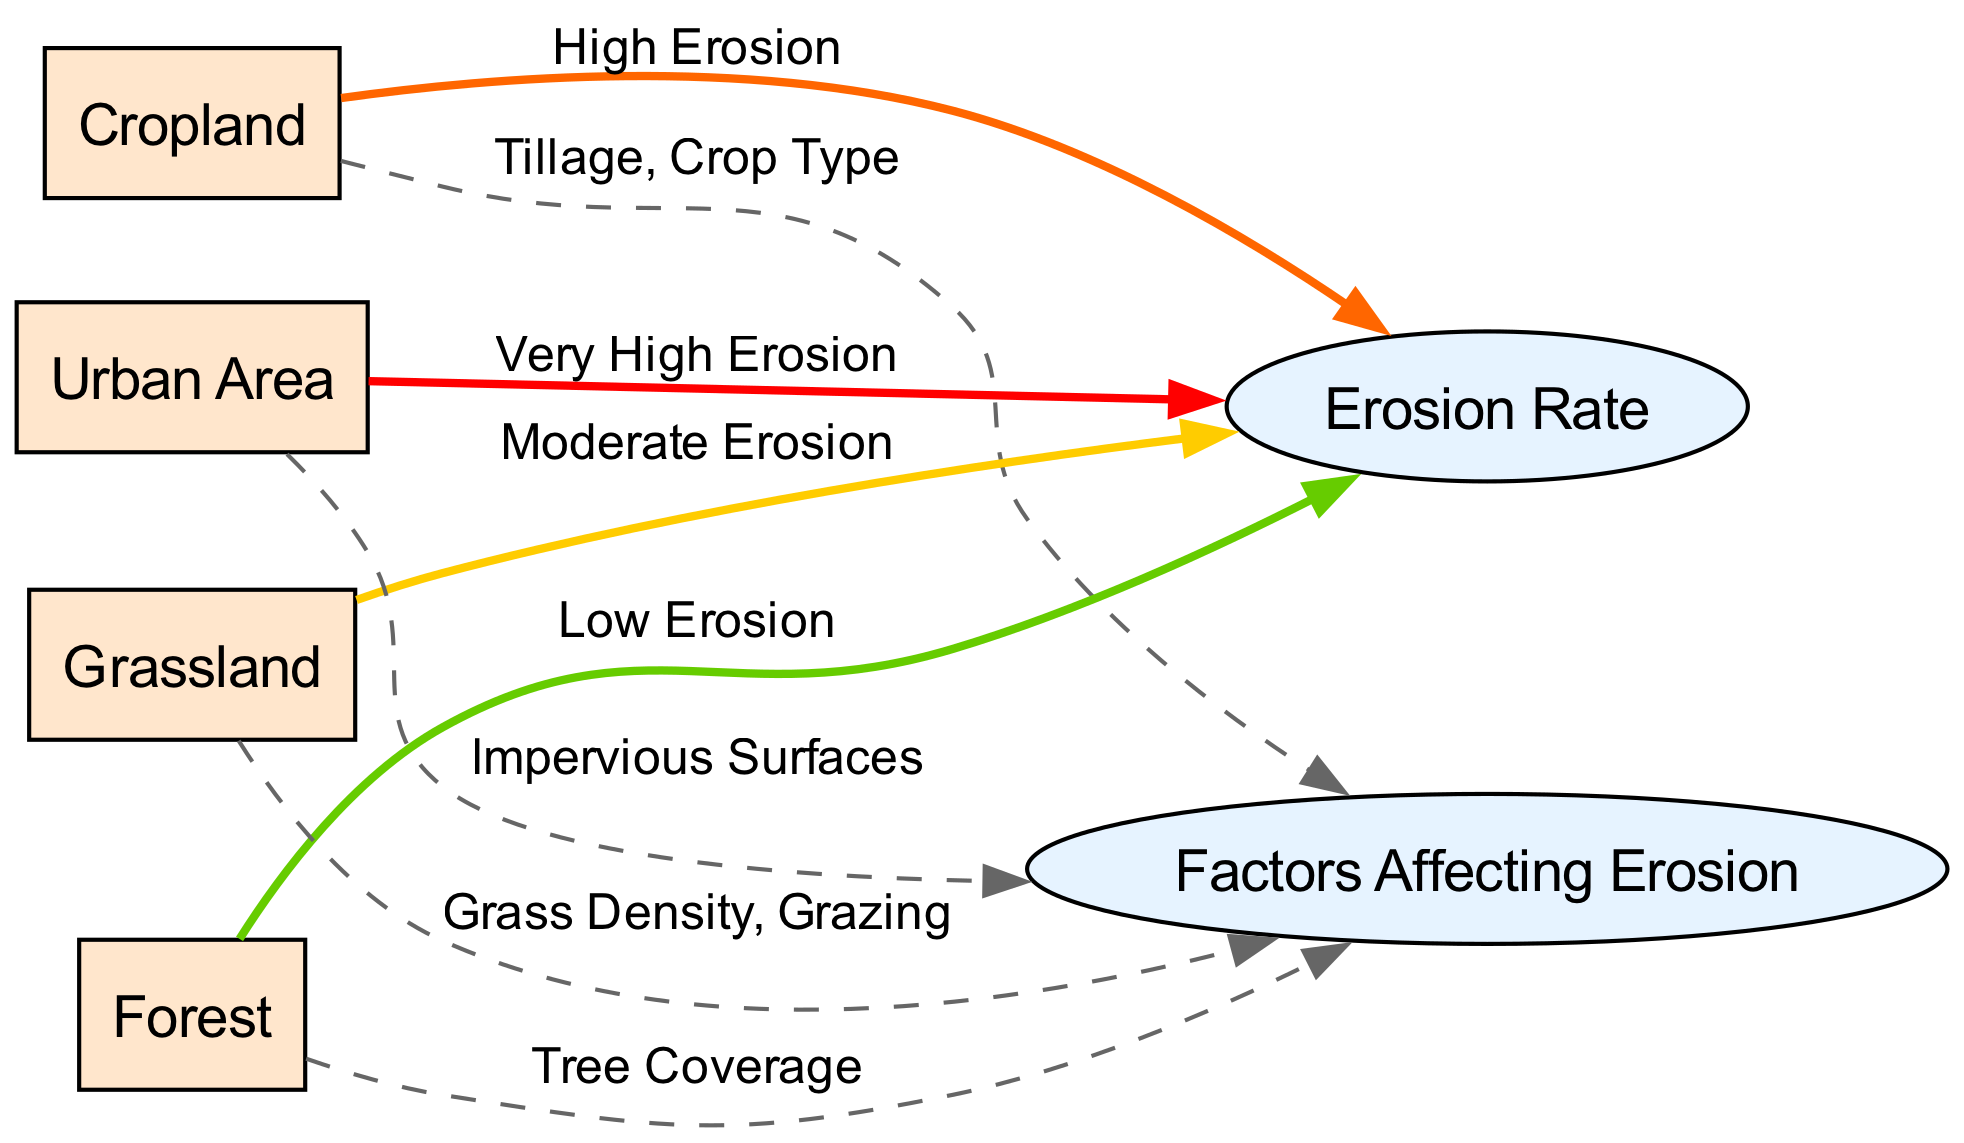What's the erosion rate associated with cropland? The diagram shows that the edge from cropland to erosion rate is labeled "High Erosion", indicating that cropland has a high erosion rate.
Answer: High Erosion Which land use has the lowest erosion rate? The edge from forest to erosion rate is labeled "Low Erosion", making it clear that forested land has the lowest erosion rate of all land uses.
Answer: Low Erosion How many types of land uses are represented in the diagram? The nodes for land use include cropland, forest, grassland, and urban area. Counting these gives a total of four distinct types of land uses.
Answer: 4 What factors affect erosion in urban areas? The edge from urban to factors is labeled "Impervious Surfaces", indicating that the primary factor affecting erosion in urban areas is the presence of impervious surfaces.
Answer: Impervious Surfaces Which land use has a moderate erosion rate? The diagram connects grassland with the label "Moderate Erosion", therefore indicating that grassland has a moderate erosion rate.
Answer: Moderate Erosion What are the factors affecting erosion in cropland? The diagram shows an edge from cropland to factors labeled "Tillage, Crop Type", which clearly states the factors that affect erosion in cropland.
Answer: Tillage, Crop Type Which land use has the highest erosion rate? Urban area is connected to erosion rate with the label "Very High Erosion", thus it indicates that among all land uses presented, urban areas experience the highest erosion rate.
Answer: Very High Erosion What relationship exists between grassland and erosion rate? The connection from grassland to erosion rate, labeled "Moderate Erosion", shows a moderate level of erosion associated with grassland.
Answer: Moderate Erosion 